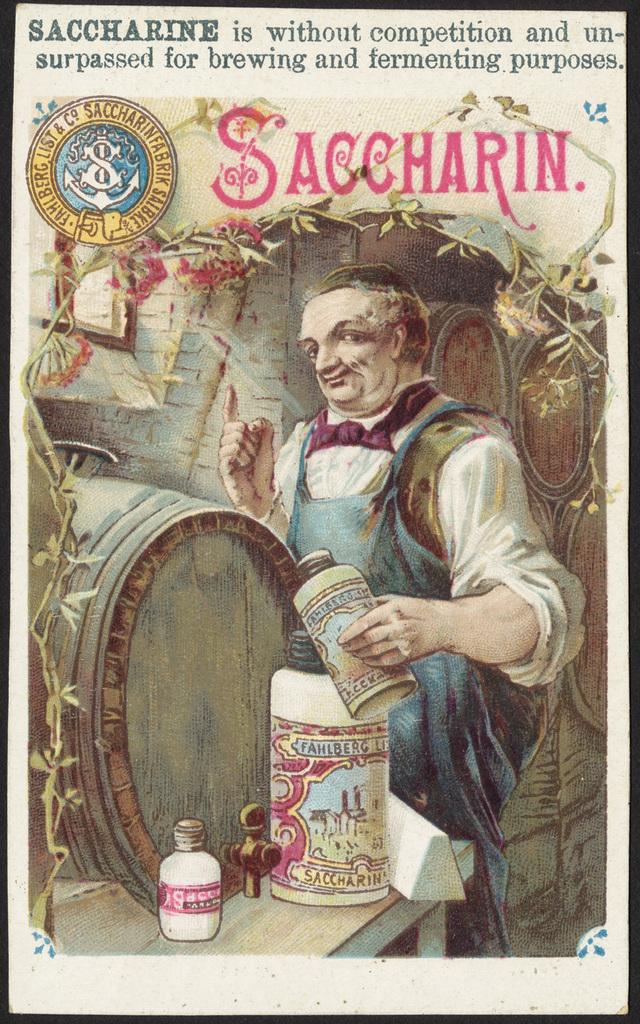What is present in the image that contains visual information? There is a paper in the image that contains pictures of a man. What is the man doing in the pictures on the paper? The man is standing on the floor in the pictures. What objects is the man holding in the pictures? The man is holding plastic containers in the pictures. What other items can be seen in the pictures on the paper? The pictures also show barrels and creeper plants. Can you tell me how many geese are present in the image? There are no geese present in the image; the pictures on the paper depict a man, plastic containers, barrels, and creeper plants. 